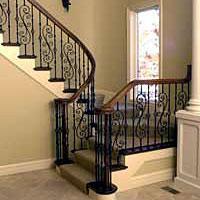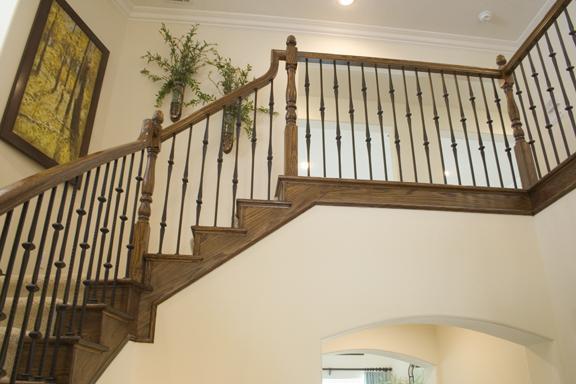The first image is the image on the left, the second image is the image on the right. Assess this claim about the two images: "There are at least four S shaped pieces of metal in the railing by the stairs.". Correct or not? Answer yes or no. Yes. The first image is the image on the left, the second image is the image on the right. For the images displayed, is the sentence "The staircase on the left has a banister featuring cast iron bars with scroll details, and the staircase on the right has slender spindles." factually correct? Answer yes or no. Yes. 